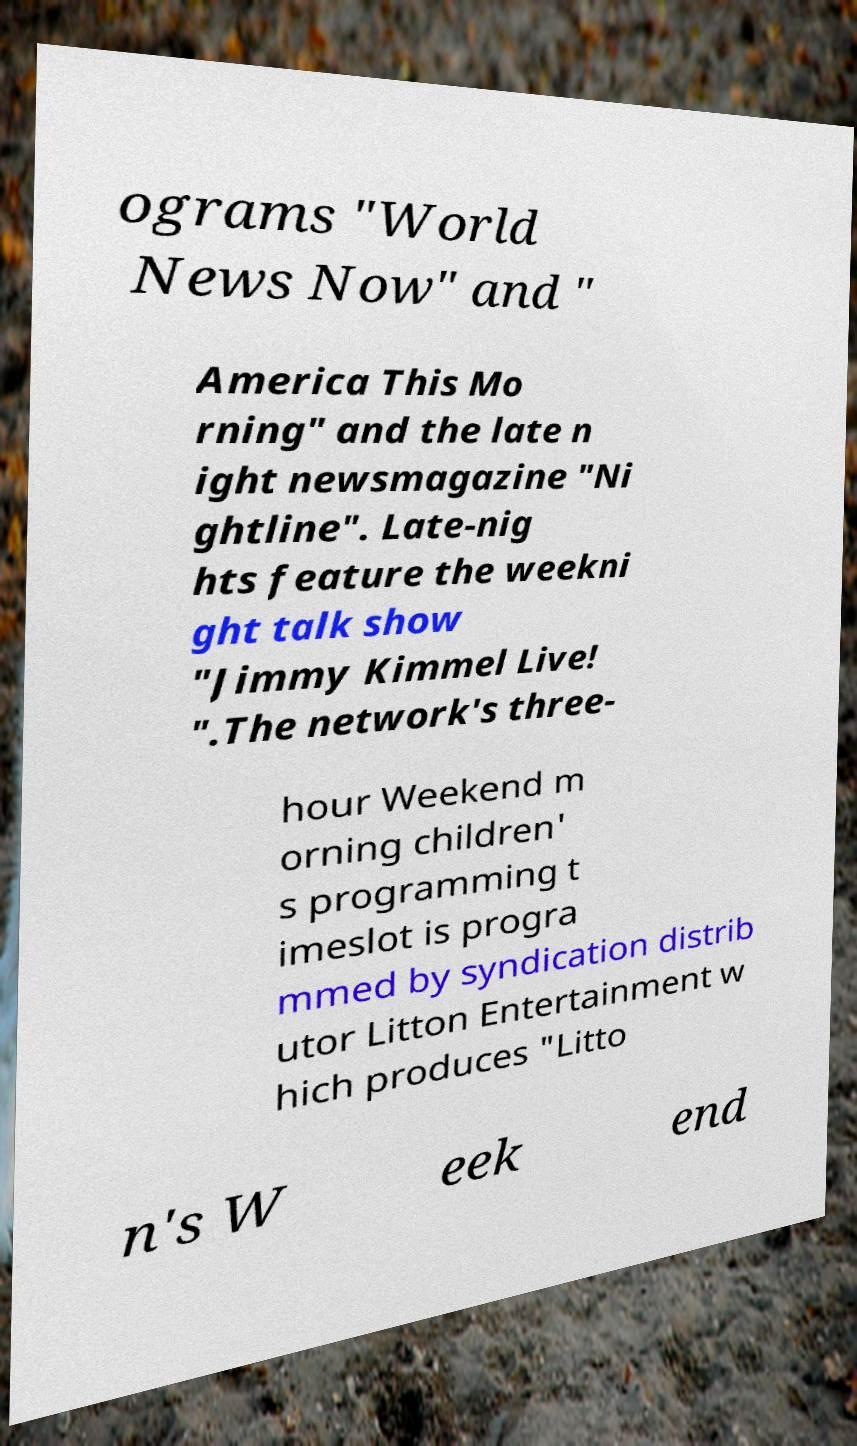Please read and relay the text visible in this image. What does it say? ograms "World News Now" and " America This Mo rning" and the late n ight newsmagazine "Ni ghtline". Late-nig hts feature the weekni ght talk show "Jimmy Kimmel Live! ".The network's three- hour Weekend m orning children' s programming t imeslot is progra mmed by syndication distrib utor Litton Entertainment w hich produces "Litto n's W eek end 